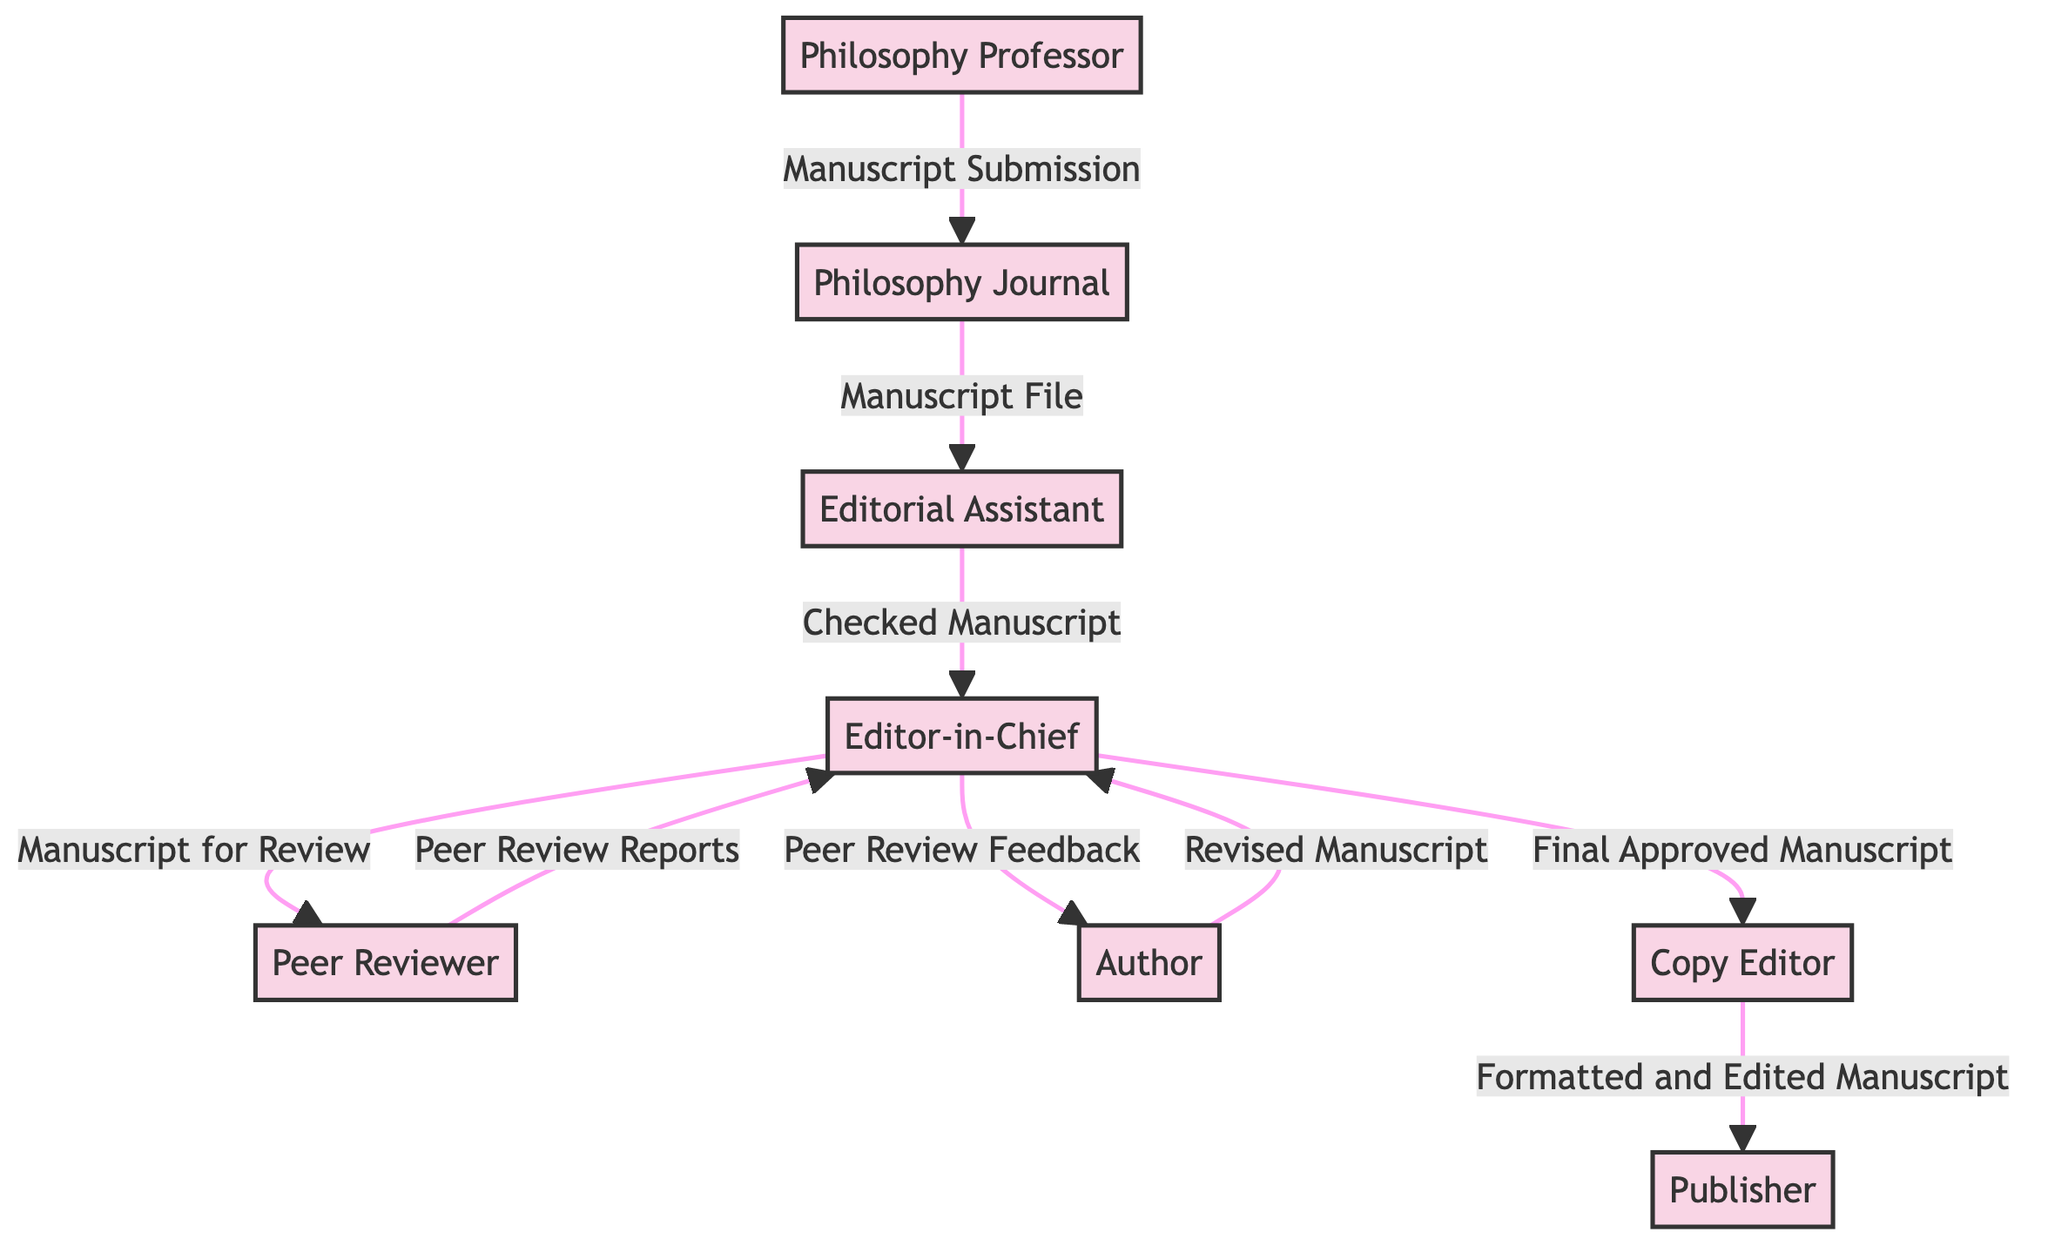What is the first entity in the diagram? The first entity in the diagram is "Philosophy Professor," as indicated by the initial arrow leading from it to the Philosophy Journal.
Answer: Philosophy Professor How many entities are present in the diagram? The diagram lists a total of eight entities, namely Philosophy Professor, Philosophy Journal, Editorial Assistant, Editor-in-Chief, Peer Reviewer, Author, Copy Editor, and Publisher.
Answer: 8 What data does the Editorial Assistant receive from the Philosophy Journal? The Editorial Assistant receives the "Manuscript File" from the Philosophy Journal, which is represented by an arrow pointing from the journal to the assistant.
Answer: Manuscript File Which entity provides feedback to the Author after the Peer Review? The Editor-in-Chief is responsible for providing the "Peer Review Feedback" to the Author, as shown by the flow from the editor to the author.
Answer: Editor-in-Chief What is the last entity involved in the publication process? The last entity involved in the process is the Publisher, as the final output of the manuscript flows to it from the Copy Editor.
Answer: Publisher Describe the relationship between the Peer Reviewer and the Editor-in-Chief. The Peer Reviewer sends "Peer Review Reports" to the Editor-in-Chief, establishing a feedback loop from the reviewer to the assessment stage.
Answer: Peer Review Reports How many data flows are there in total? There are nine data flows in total connecting various entities, each representing a distinct step or piece of information exchanged throughout the publication workflow.
Answer: 9 What does the Copy Editor handle after the final approval? The Copy Editor handles the "Formatted and Edited Manuscript" after the manuscript has received final approval from the Editor-in-Chief.
Answer: Formatted and Edited Manuscript What action does the Author take after receiving peer review feedback? Upon receiving "Peer Review Feedback," the Author revises the manuscript accordingly, as indicated by the arrow pointing from the Author back to the Editor-in-Chief.
Answer: Revised Manuscript 